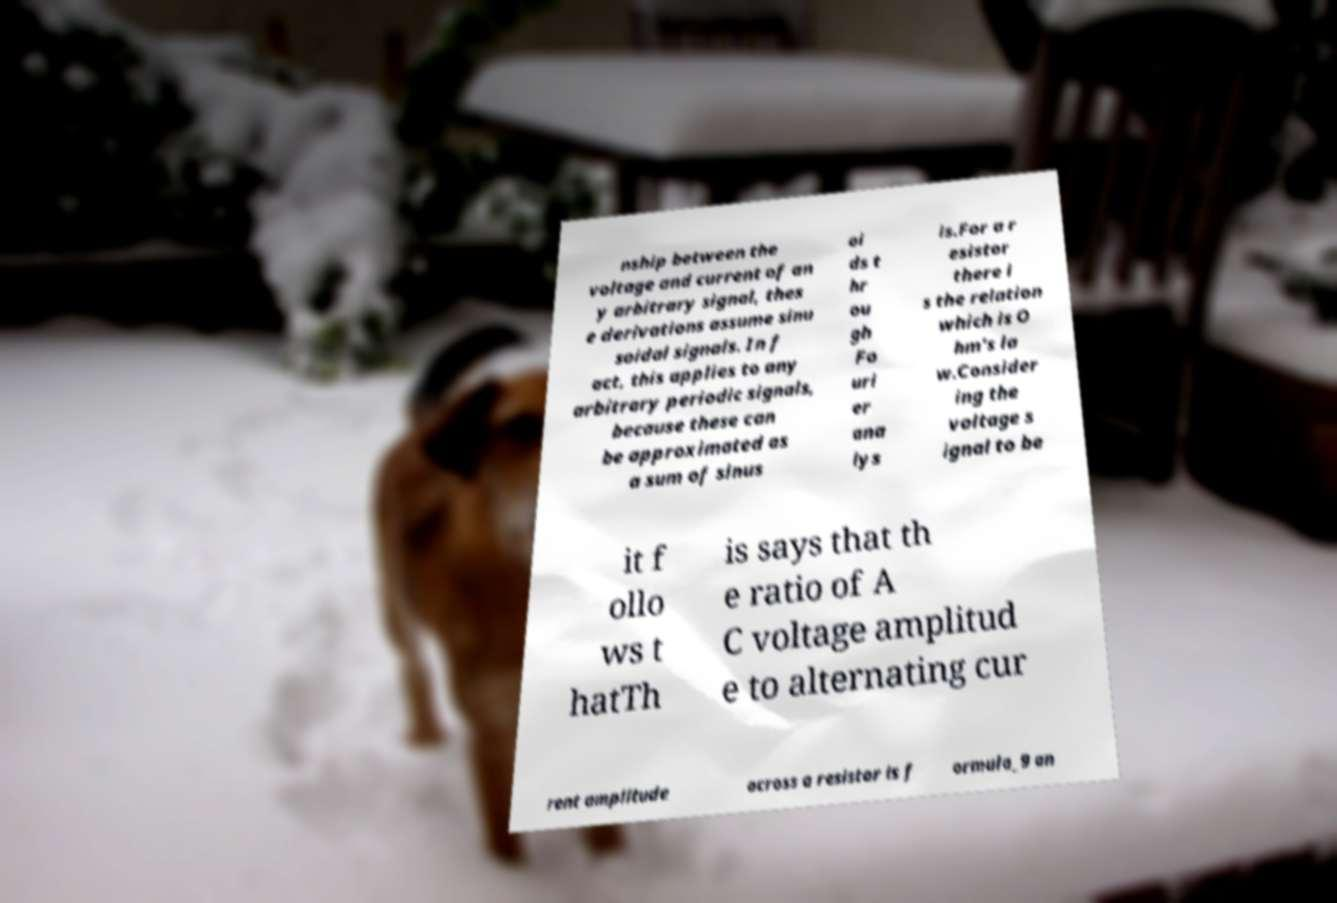I need the written content from this picture converted into text. Can you do that? nship between the voltage and current of an y arbitrary signal, thes e derivations assume sinu soidal signals. In f act, this applies to any arbitrary periodic signals, because these can be approximated as a sum of sinus oi ds t hr ou gh Fo uri er ana lys is.For a r esistor there i s the relation which is O hm's la w.Consider ing the voltage s ignal to be it f ollo ws t hatTh is says that th e ratio of A C voltage amplitud e to alternating cur rent amplitude across a resistor is f ormula_9 an 